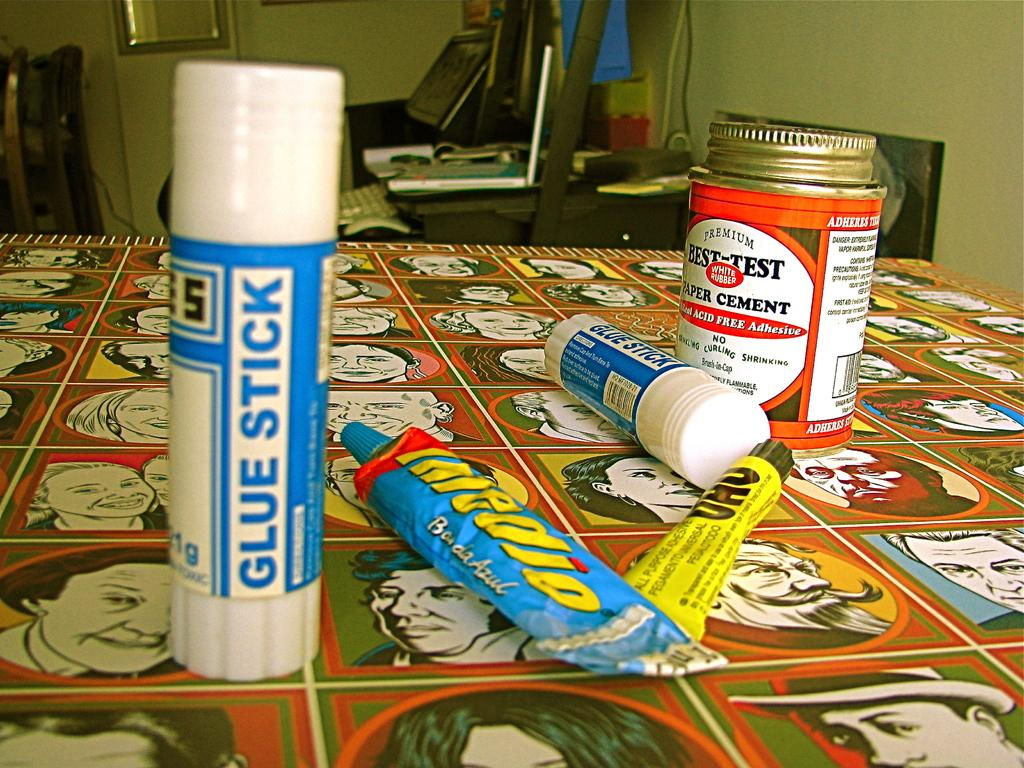Provide a one-sentence caption for the provided image. a blue and white item that has glue stick written on it. 